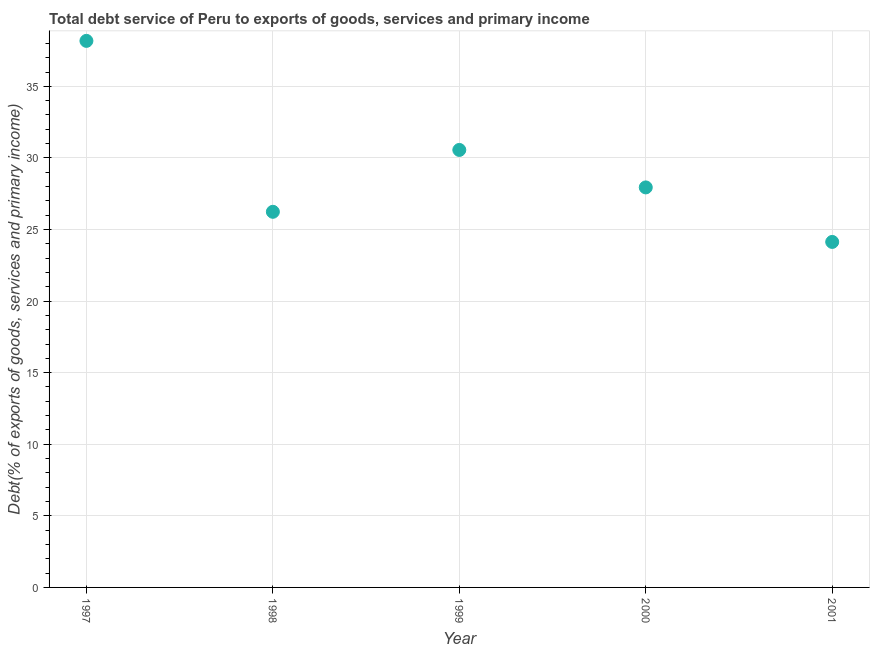What is the total debt service in 1997?
Offer a very short reply. 38.18. Across all years, what is the maximum total debt service?
Keep it short and to the point. 38.18. Across all years, what is the minimum total debt service?
Your answer should be very brief. 24.13. What is the sum of the total debt service?
Offer a terse response. 147.04. What is the difference between the total debt service in 1997 and 2000?
Your answer should be compact. 10.24. What is the average total debt service per year?
Ensure brevity in your answer.  29.41. What is the median total debt service?
Offer a terse response. 27.94. Do a majority of the years between 1998 and 1999 (inclusive) have total debt service greater than 16 %?
Provide a short and direct response. Yes. What is the ratio of the total debt service in 1998 to that in 2001?
Make the answer very short. 1.09. Is the total debt service in 1998 less than that in 2000?
Offer a terse response. Yes. Is the difference between the total debt service in 1997 and 2000 greater than the difference between any two years?
Make the answer very short. No. What is the difference between the highest and the second highest total debt service?
Offer a very short reply. 7.62. What is the difference between the highest and the lowest total debt service?
Provide a succinct answer. 14.04. In how many years, is the total debt service greater than the average total debt service taken over all years?
Provide a short and direct response. 2. How many dotlines are there?
Provide a succinct answer. 1. Does the graph contain any zero values?
Provide a succinct answer. No. Does the graph contain grids?
Provide a short and direct response. Yes. What is the title of the graph?
Your answer should be compact. Total debt service of Peru to exports of goods, services and primary income. What is the label or title of the X-axis?
Provide a succinct answer. Year. What is the label or title of the Y-axis?
Give a very brief answer. Debt(% of exports of goods, services and primary income). What is the Debt(% of exports of goods, services and primary income) in 1997?
Your response must be concise. 38.18. What is the Debt(% of exports of goods, services and primary income) in 1998?
Provide a succinct answer. 26.24. What is the Debt(% of exports of goods, services and primary income) in 1999?
Make the answer very short. 30.56. What is the Debt(% of exports of goods, services and primary income) in 2000?
Your answer should be very brief. 27.94. What is the Debt(% of exports of goods, services and primary income) in 2001?
Your answer should be very brief. 24.13. What is the difference between the Debt(% of exports of goods, services and primary income) in 1997 and 1998?
Your answer should be very brief. 11.94. What is the difference between the Debt(% of exports of goods, services and primary income) in 1997 and 1999?
Provide a short and direct response. 7.62. What is the difference between the Debt(% of exports of goods, services and primary income) in 1997 and 2000?
Give a very brief answer. 10.24. What is the difference between the Debt(% of exports of goods, services and primary income) in 1997 and 2001?
Keep it short and to the point. 14.04. What is the difference between the Debt(% of exports of goods, services and primary income) in 1998 and 1999?
Your answer should be compact. -4.32. What is the difference between the Debt(% of exports of goods, services and primary income) in 1998 and 2000?
Make the answer very short. -1.7. What is the difference between the Debt(% of exports of goods, services and primary income) in 1998 and 2001?
Ensure brevity in your answer.  2.1. What is the difference between the Debt(% of exports of goods, services and primary income) in 1999 and 2000?
Provide a short and direct response. 2.62. What is the difference between the Debt(% of exports of goods, services and primary income) in 1999 and 2001?
Give a very brief answer. 6.43. What is the difference between the Debt(% of exports of goods, services and primary income) in 2000 and 2001?
Provide a succinct answer. 3.81. What is the ratio of the Debt(% of exports of goods, services and primary income) in 1997 to that in 1998?
Offer a terse response. 1.46. What is the ratio of the Debt(% of exports of goods, services and primary income) in 1997 to that in 1999?
Keep it short and to the point. 1.25. What is the ratio of the Debt(% of exports of goods, services and primary income) in 1997 to that in 2000?
Offer a very short reply. 1.37. What is the ratio of the Debt(% of exports of goods, services and primary income) in 1997 to that in 2001?
Make the answer very short. 1.58. What is the ratio of the Debt(% of exports of goods, services and primary income) in 1998 to that in 1999?
Your answer should be very brief. 0.86. What is the ratio of the Debt(% of exports of goods, services and primary income) in 1998 to that in 2000?
Your answer should be compact. 0.94. What is the ratio of the Debt(% of exports of goods, services and primary income) in 1998 to that in 2001?
Your response must be concise. 1.09. What is the ratio of the Debt(% of exports of goods, services and primary income) in 1999 to that in 2000?
Keep it short and to the point. 1.09. What is the ratio of the Debt(% of exports of goods, services and primary income) in 1999 to that in 2001?
Your answer should be very brief. 1.27. What is the ratio of the Debt(% of exports of goods, services and primary income) in 2000 to that in 2001?
Make the answer very short. 1.16. 